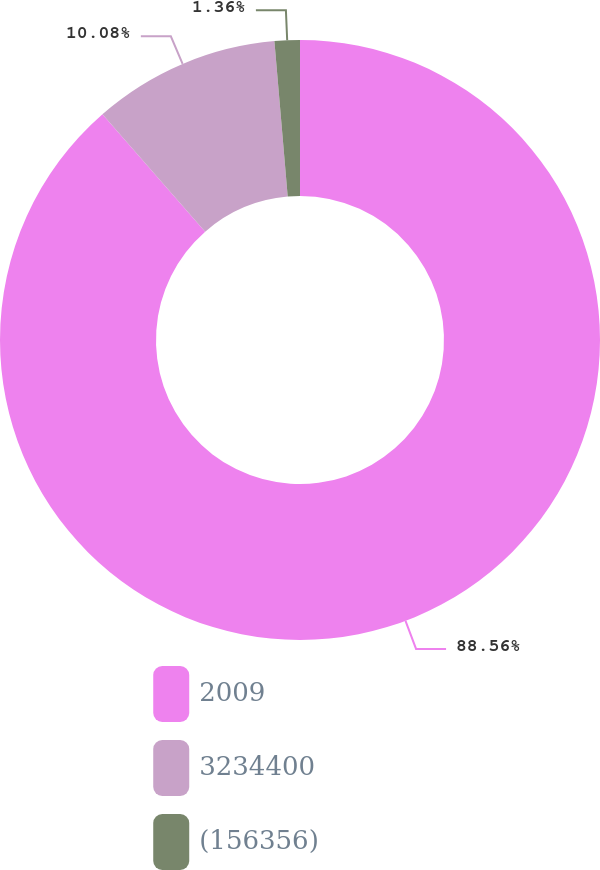Convert chart to OTSL. <chart><loc_0><loc_0><loc_500><loc_500><pie_chart><fcel>2009<fcel>3234400<fcel>(156356)<nl><fcel>88.56%<fcel>10.08%<fcel>1.36%<nl></chart> 